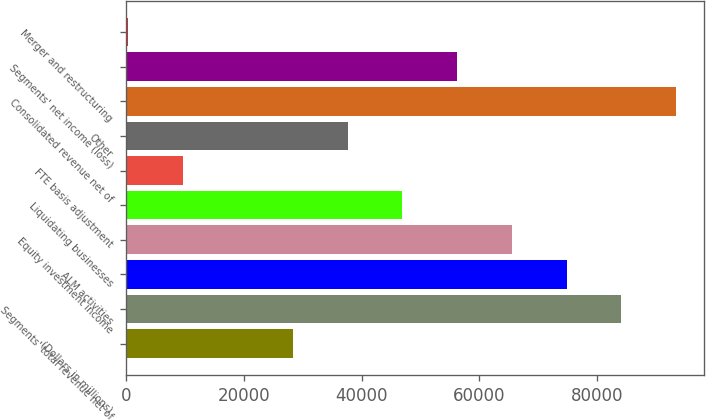Convert chart. <chart><loc_0><loc_0><loc_500><loc_500><bar_chart><fcel>(Dollars in millions)<fcel>Segments' total revenue net of<fcel>ALM activities<fcel>Equity investment income<fcel>Liquidating businesses<fcel>FTE basis adjustment<fcel>Other<fcel>Consolidated revenue net of<fcel>Segments' net income (loss)<fcel>Merger and restructuring<nl><fcel>28317.6<fcel>84148.8<fcel>74843.6<fcel>65538.4<fcel>46928<fcel>9707.2<fcel>37622.8<fcel>93454<fcel>56233.2<fcel>402<nl></chart> 